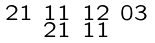Convert formula to latex. <formula><loc_0><loc_0><loc_500><loc_500>\begin{smallmatrix} 2 1 & 1 1 & 1 2 & 0 3 \\ & 2 1 & 1 1 \end{smallmatrix}</formula> 